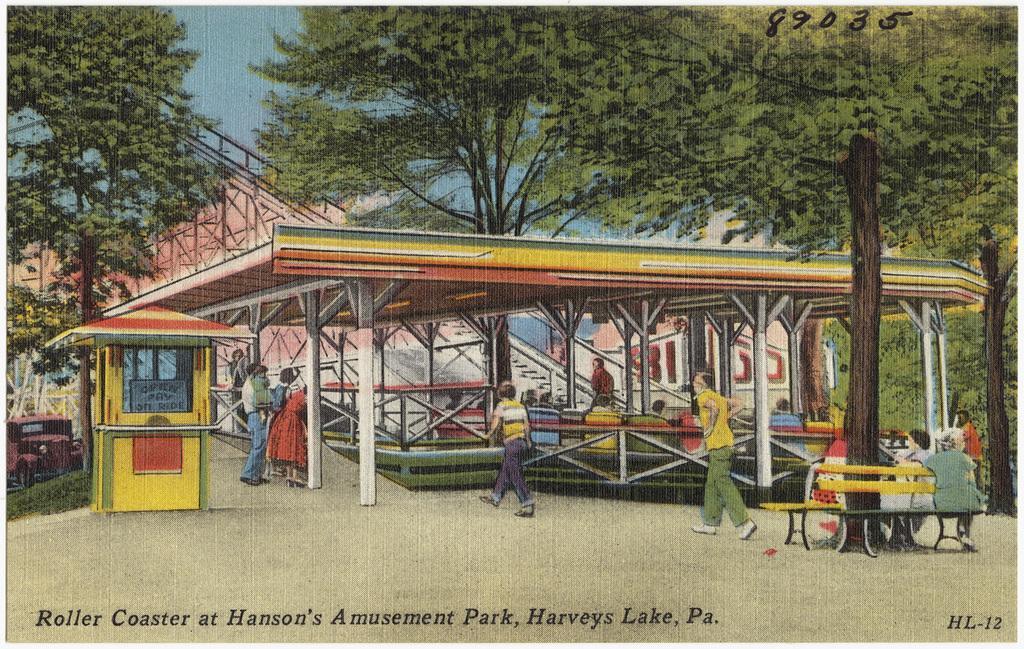In one or two sentences, can you explain what this image depicts? In the center of the image there is a shed and there are people walking. On the right there are benches and we can see people sitting on the bench. In the background there are trees and sky. On the left there is a vehicle. At the bottom there is a road. 